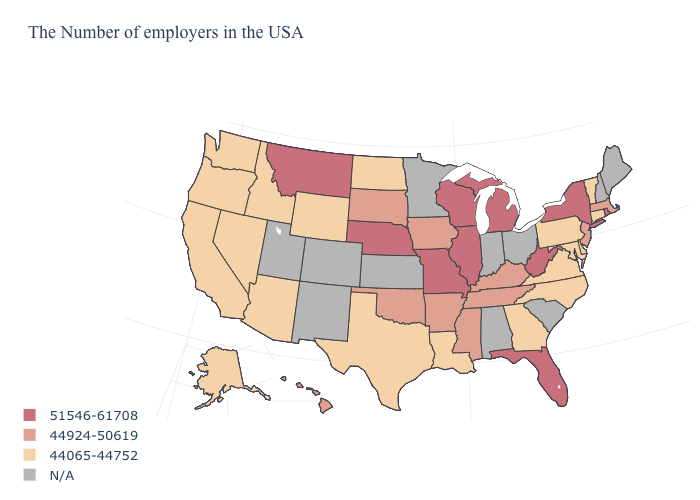Which states have the lowest value in the USA?
Give a very brief answer. Vermont, Connecticut, Delaware, Maryland, Pennsylvania, Virginia, North Carolina, Georgia, Louisiana, Texas, North Dakota, Wyoming, Arizona, Idaho, Nevada, California, Washington, Oregon, Alaska. Does New York have the highest value in the USA?
Be succinct. Yes. Among the states that border Rhode Island , which have the lowest value?
Write a very short answer. Connecticut. What is the value of South Dakota?
Answer briefly. 44924-50619. What is the lowest value in the USA?
Concise answer only. 44065-44752. Does the map have missing data?
Be succinct. Yes. What is the highest value in the South ?
Quick response, please. 51546-61708. Among the states that border Oklahoma , which have the highest value?
Short answer required. Missouri. What is the value of Alabama?
Concise answer only. N/A. Name the states that have a value in the range 51546-61708?
Short answer required. Rhode Island, New York, West Virginia, Florida, Michigan, Wisconsin, Illinois, Missouri, Nebraska, Montana. Does the first symbol in the legend represent the smallest category?
Quick response, please. No. Is the legend a continuous bar?
Be succinct. No. What is the highest value in the USA?
Write a very short answer. 51546-61708. 